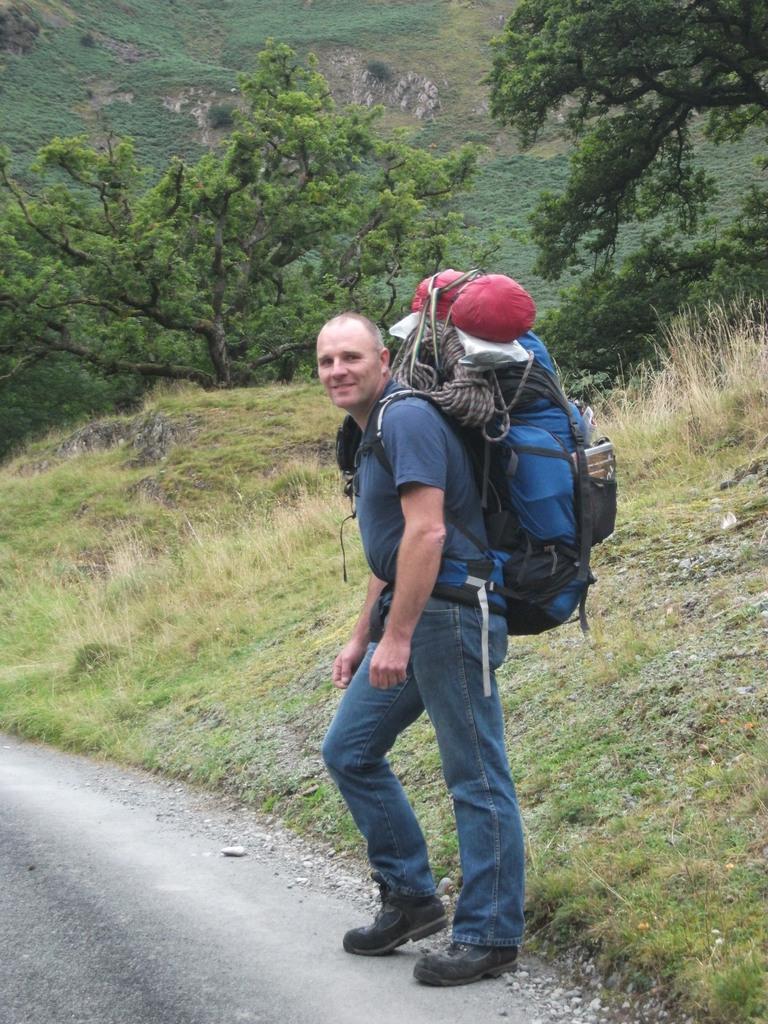Describe this image in one or two sentences. A person is standing on a road wearing a travel bag on his shoulders, beside him there are trees and mountains and grass too. 